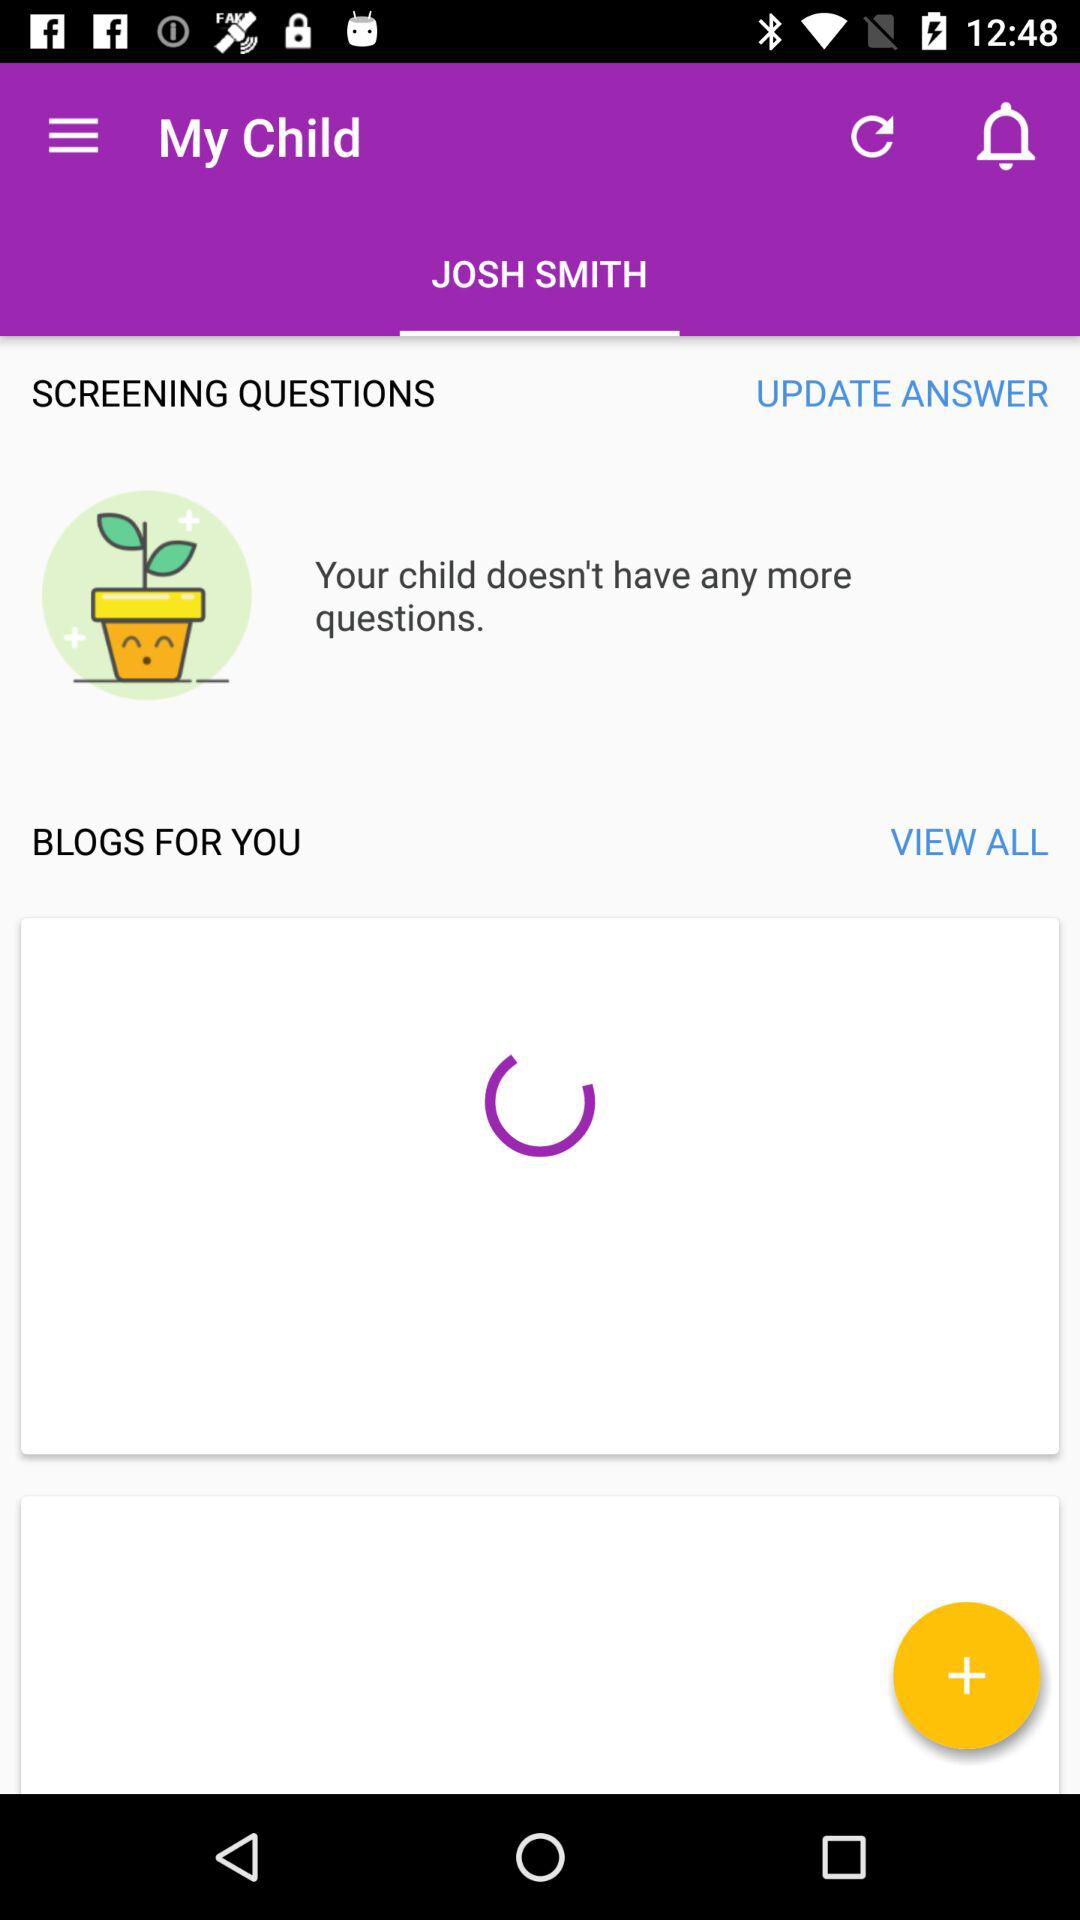What is the name of the child? The name of the child is Josh Smith. 